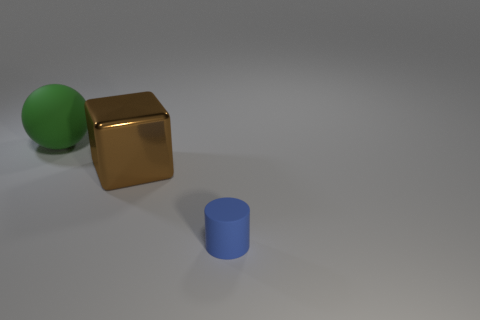There is a rubber object that is in front of the large rubber ball; does it have the same shape as the big green matte object?
Ensure brevity in your answer.  No. What number of objects are green matte objects or objects that are in front of the big green object?
Your answer should be compact. 3. Are there fewer small purple cylinders than blue objects?
Offer a very short reply. Yes. Are there more tiny blue shiny cubes than large green rubber spheres?
Keep it short and to the point. No. How many other objects are the same material as the brown block?
Give a very brief answer. 0. There is a matte object that is to the left of the rubber thing in front of the shiny object; what number of big green things are behind it?
Provide a short and direct response. 0. What number of shiny objects are tiny purple blocks or green balls?
Give a very brief answer. 0. There is a rubber object that is to the right of the object behind the big shiny block; how big is it?
Make the answer very short. Small. There is a big object in front of the matte sphere; is its color the same as the matte thing right of the large green object?
Give a very brief answer. No. There is a thing that is both behind the cylinder and in front of the green sphere; what is its color?
Make the answer very short. Brown. 